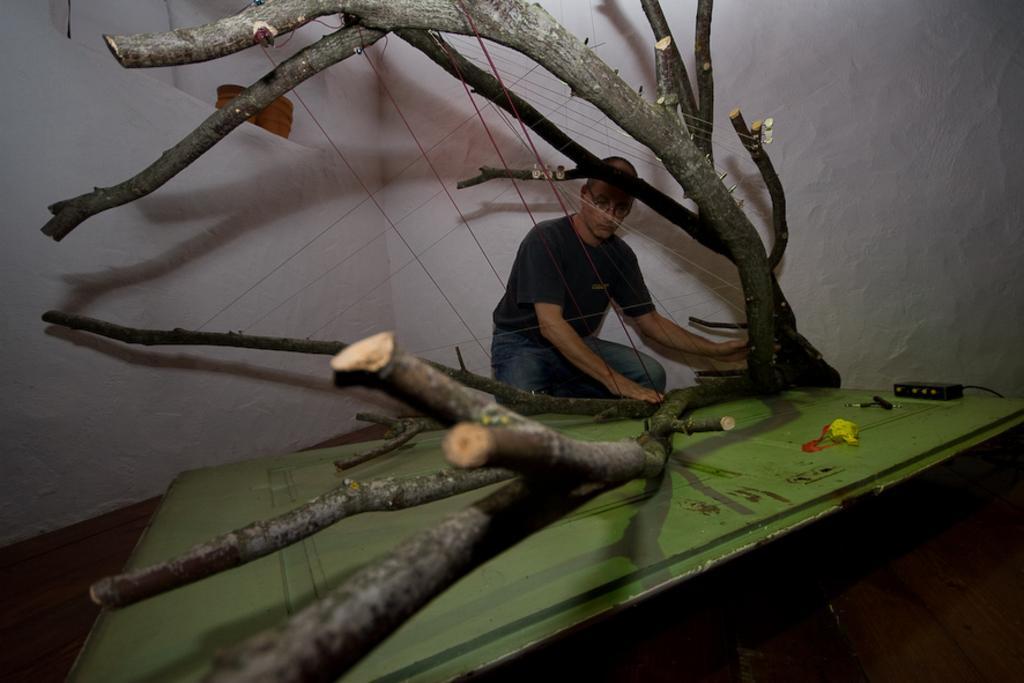Can you describe this image briefly? In the middle of this image, there is a tree having branches and having tied with threads. Beside this tree, there is a person. In front of this person, there is a green color wooden surface, on which there are some objects. In the background, there is a white wall. 